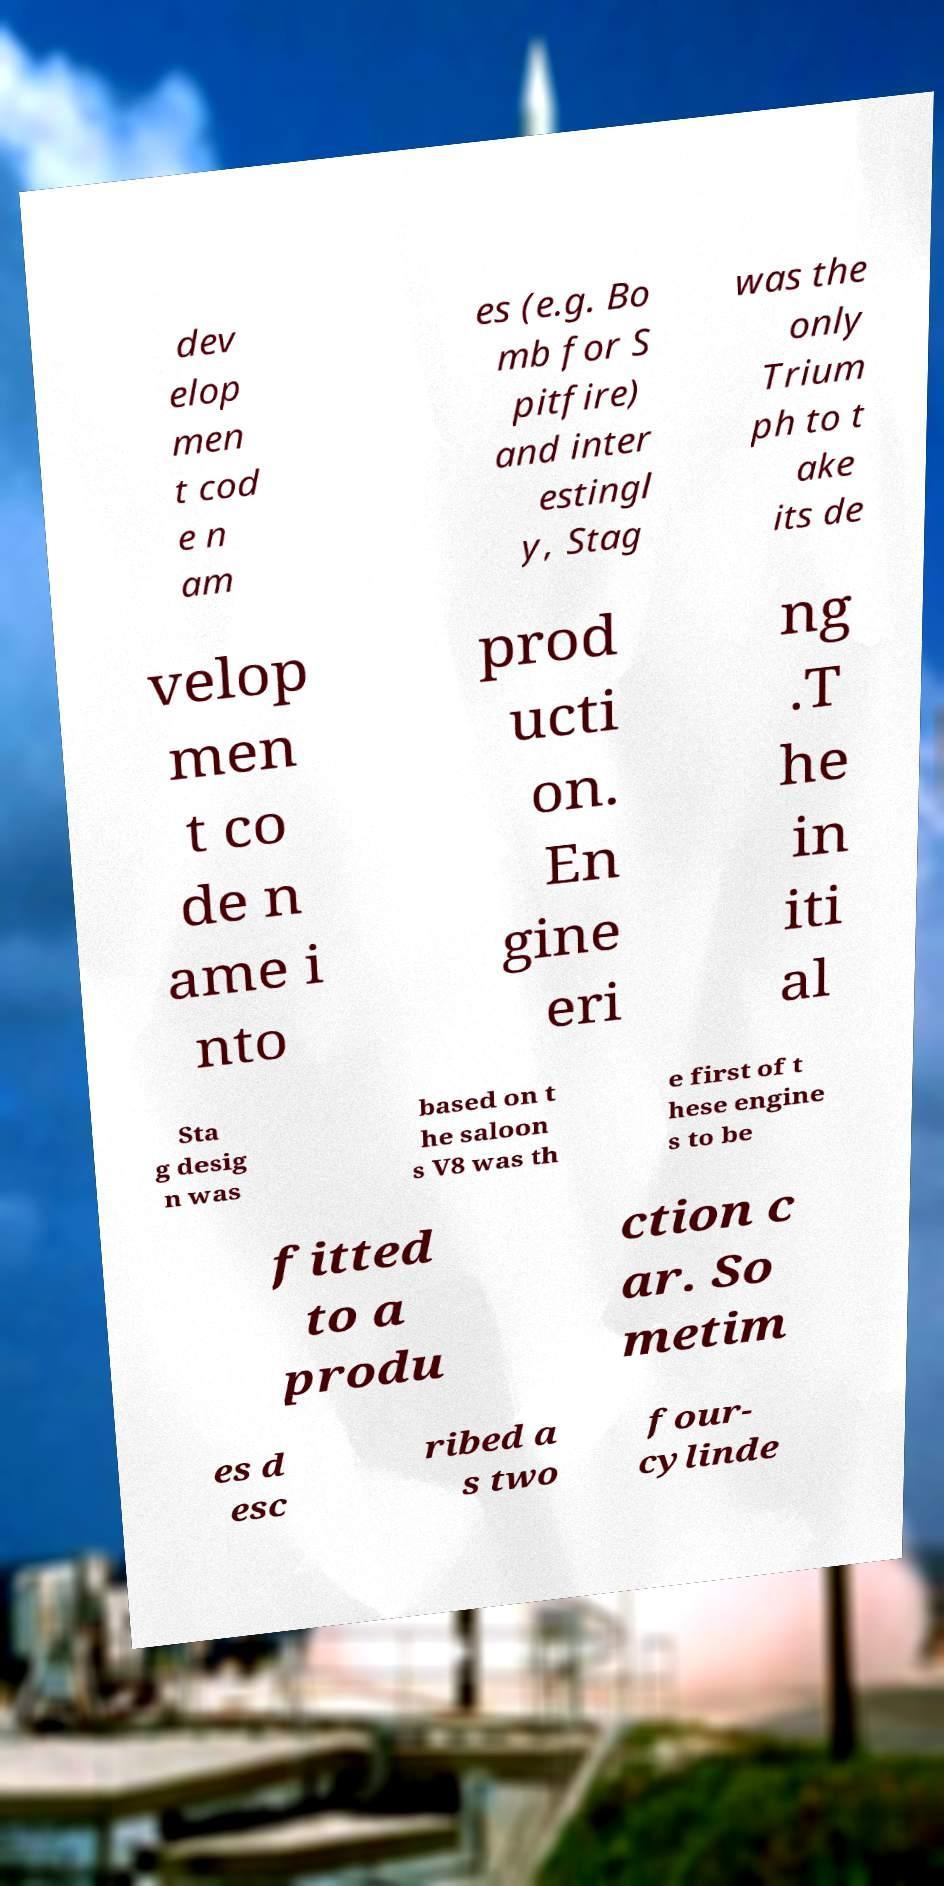Can you read and provide the text displayed in the image?This photo seems to have some interesting text. Can you extract and type it out for me? dev elop men t cod e n am es (e.g. Bo mb for S pitfire) and inter estingl y, Stag was the only Trium ph to t ake its de velop men t co de n ame i nto prod ucti on. En gine eri ng .T he in iti al Sta g desig n was based on t he saloon s V8 was th e first of t hese engine s to be fitted to a produ ction c ar. So metim es d esc ribed a s two four- cylinde 